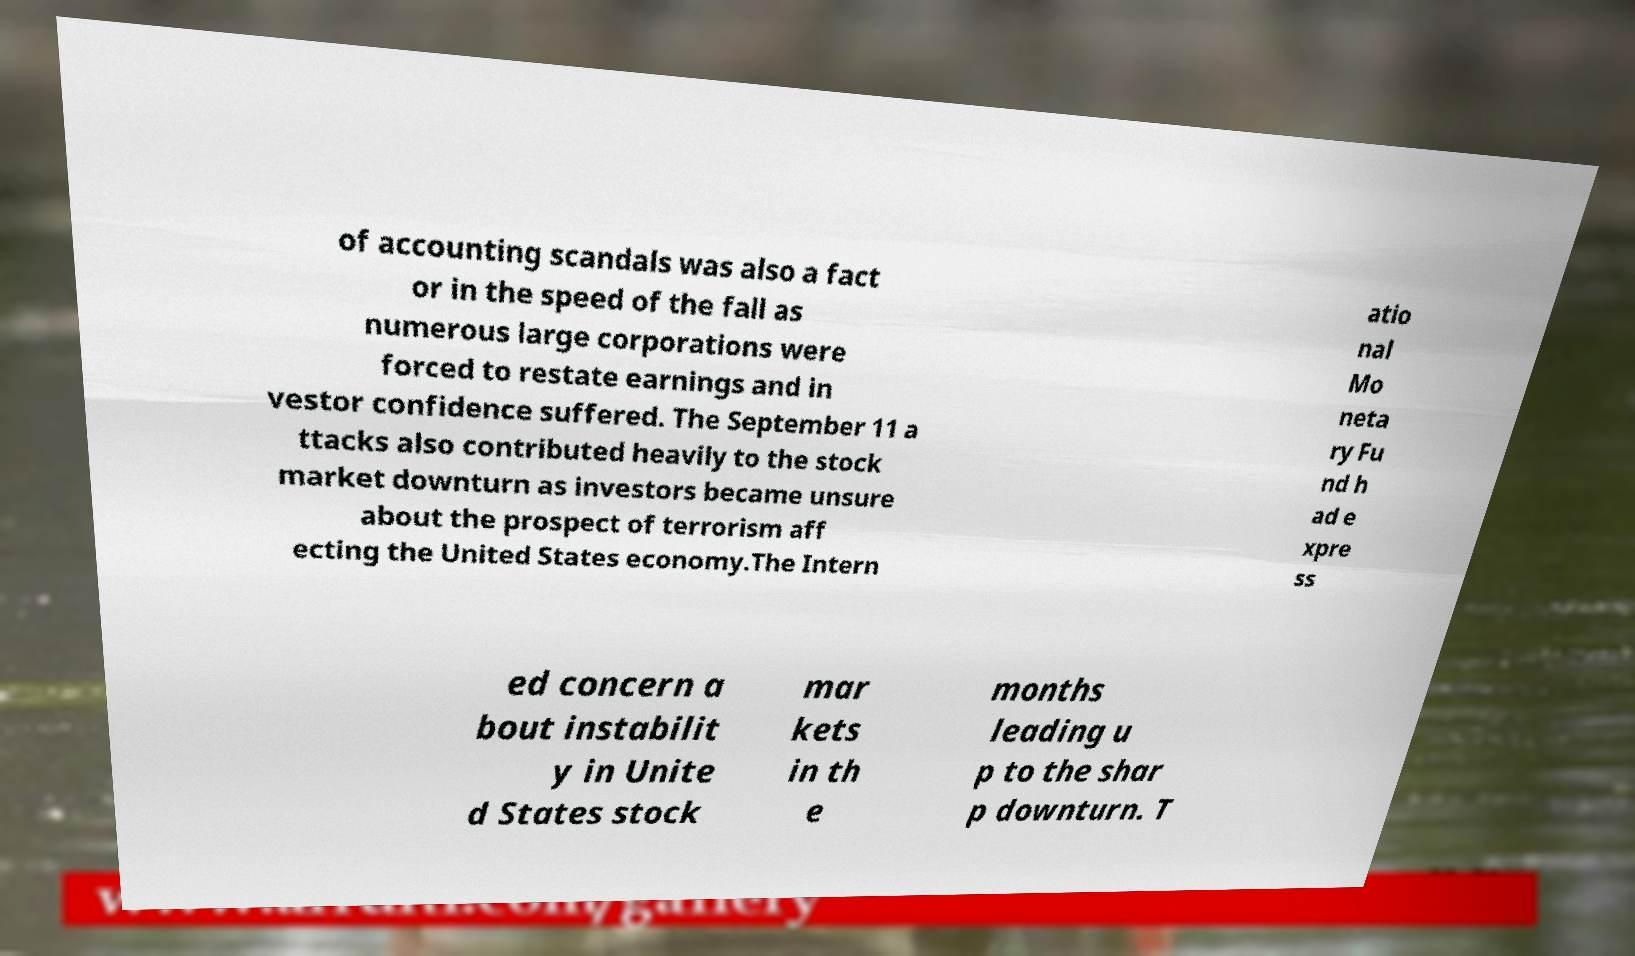For documentation purposes, I need the text within this image transcribed. Could you provide that? of accounting scandals was also a fact or in the speed of the fall as numerous large corporations were forced to restate earnings and in vestor confidence suffered. The September 11 a ttacks also contributed heavily to the stock market downturn as investors became unsure about the prospect of terrorism aff ecting the United States economy.The Intern atio nal Mo neta ry Fu nd h ad e xpre ss ed concern a bout instabilit y in Unite d States stock mar kets in th e months leading u p to the shar p downturn. T 